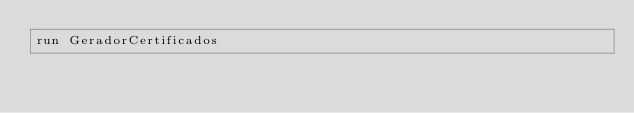Convert code to text. <code><loc_0><loc_0><loc_500><loc_500><_Ruby_>run GeradorCertificados
</code> 